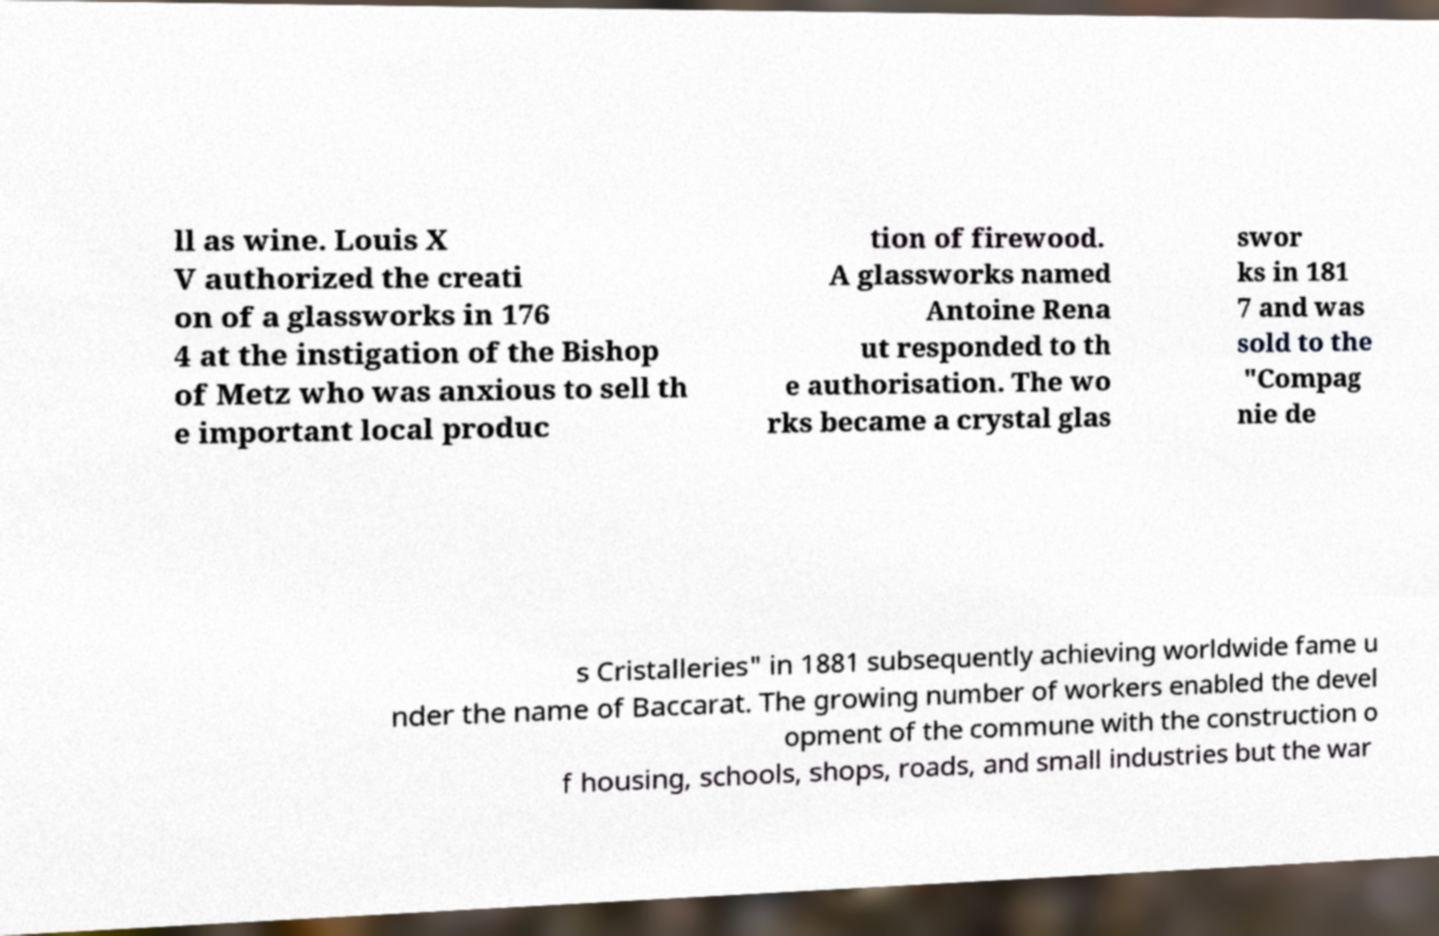What messages or text are displayed in this image? I need them in a readable, typed format. ll as wine. Louis X V authorized the creati on of a glassworks in 176 4 at the instigation of the Bishop of Metz who was anxious to sell th e important local produc tion of firewood. A glassworks named Antoine Rena ut responded to th e authorisation. The wo rks became a crystal glas swor ks in 181 7 and was sold to the "Compag nie de s Cristalleries" in 1881 subsequently achieving worldwide fame u nder the name of Baccarat. The growing number of workers enabled the devel opment of the commune with the construction o f housing, schools, shops, roads, and small industries but the war 